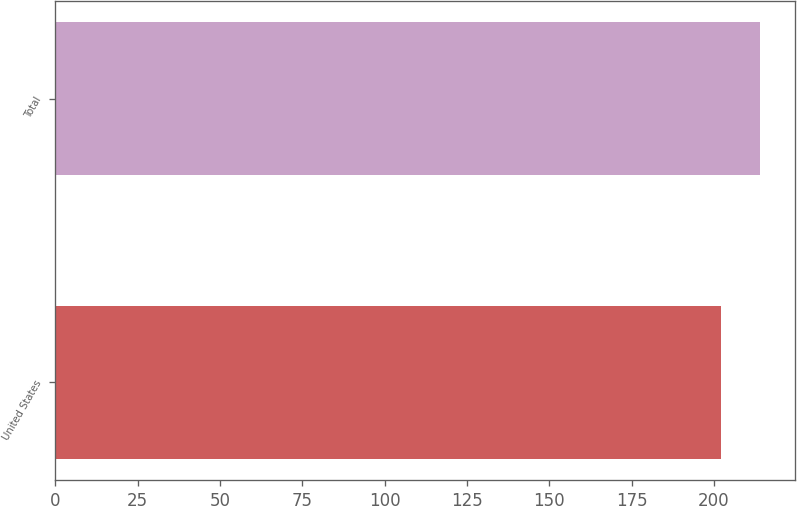Convert chart. <chart><loc_0><loc_0><loc_500><loc_500><bar_chart><fcel>United States<fcel>Total<nl><fcel>202<fcel>214<nl></chart> 